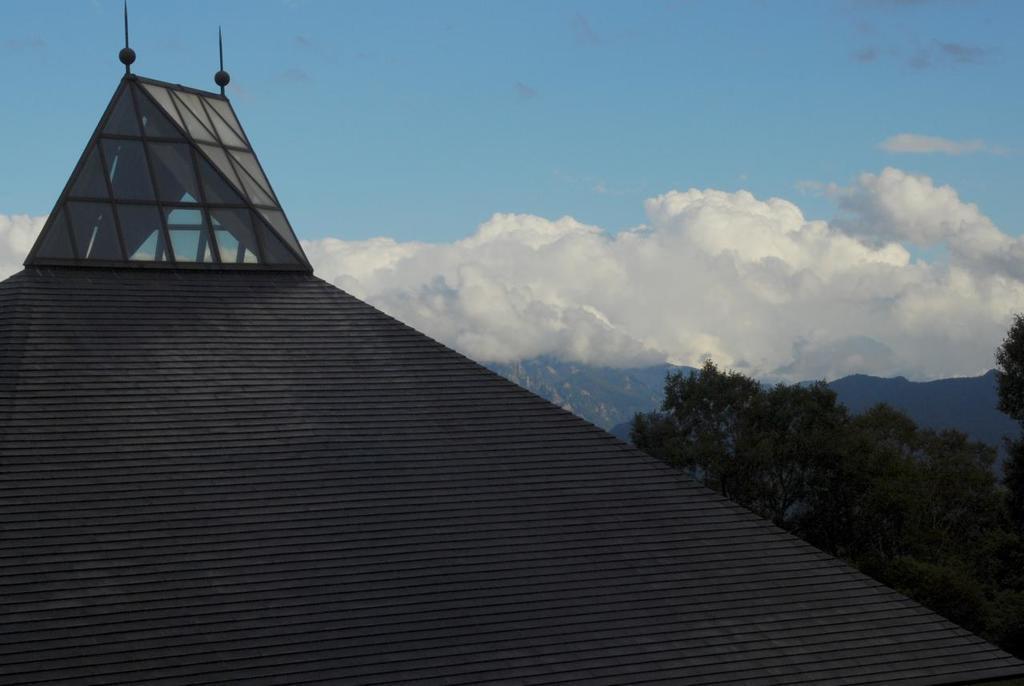How would you summarize this image in a sentence or two? In this image I can see the dome. In the background I can see few trees in green color and the sky is in white and blue color. 